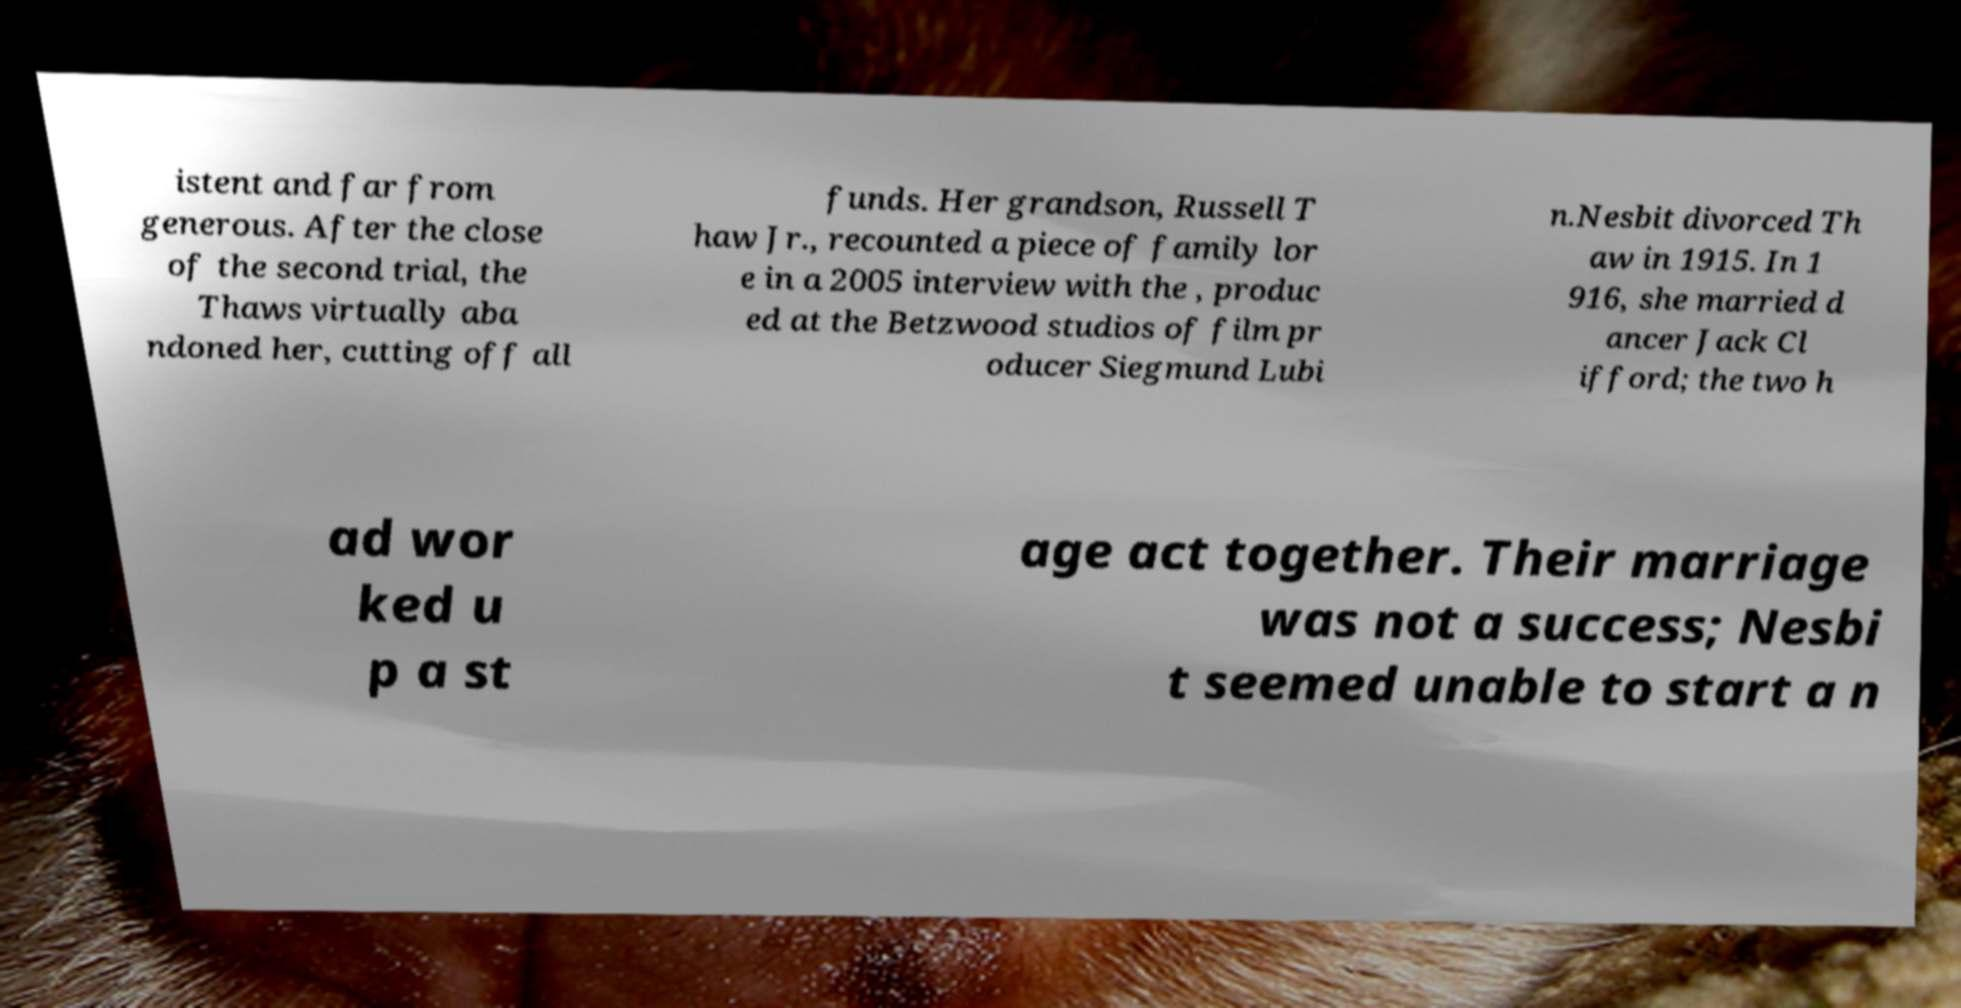Could you assist in decoding the text presented in this image and type it out clearly? istent and far from generous. After the close of the second trial, the Thaws virtually aba ndoned her, cutting off all funds. Her grandson, Russell T haw Jr., recounted a piece of family lor e in a 2005 interview with the , produc ed at the Betzwood studios of film pr oducer Siegmund Lubi n.Nesbit divorced Th aw in 1915. In 1 916, she married d ancer Jack Cl ifford; the two h ad wor ked u p a st age act together. Their marriage was not a success; Nesbi t seemed unable to start a n 